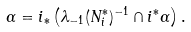Convert formula to latex. <formula><loc_0><loc_0><loc_500><loc_500>\alpha = i _ { * } \left ( \lambda _ { - 1 } ( N _ { i } ^ { * } ) ^ { - 1 } \cap i ^ { * } \alpha \right ) .</formula> 